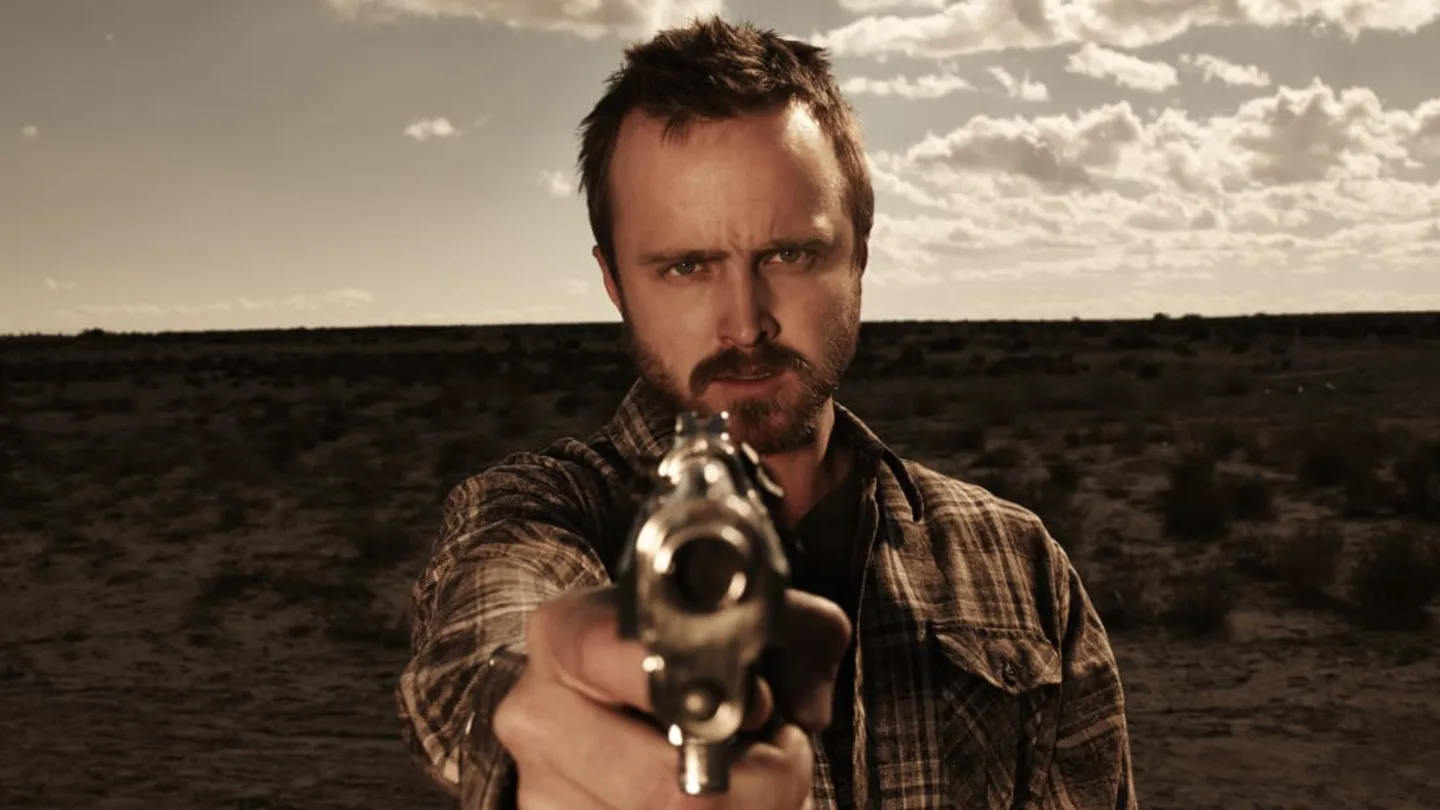How does the setting enhance the mood of this image? The desert setting contributes significantly to the mood of the image. The vast and barren landscape under a cloudy sky creates a feeling of isolation and perhaps desolation, which complements the grim expression and aggressive stance of the subject. This combination evokes a dramatic and somewhat suspenseful atmosphere. 